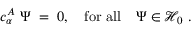Convert formula to latex. <formula><loc_0><loc_0><loc_500><loc_500>c _ { \alpha } ^ { A } \ \Psi \, = \, 0 , \quad f o r \ a l l \quad \Psi \in { \mathcal { H } } _ { 0 } \ .</formula> 